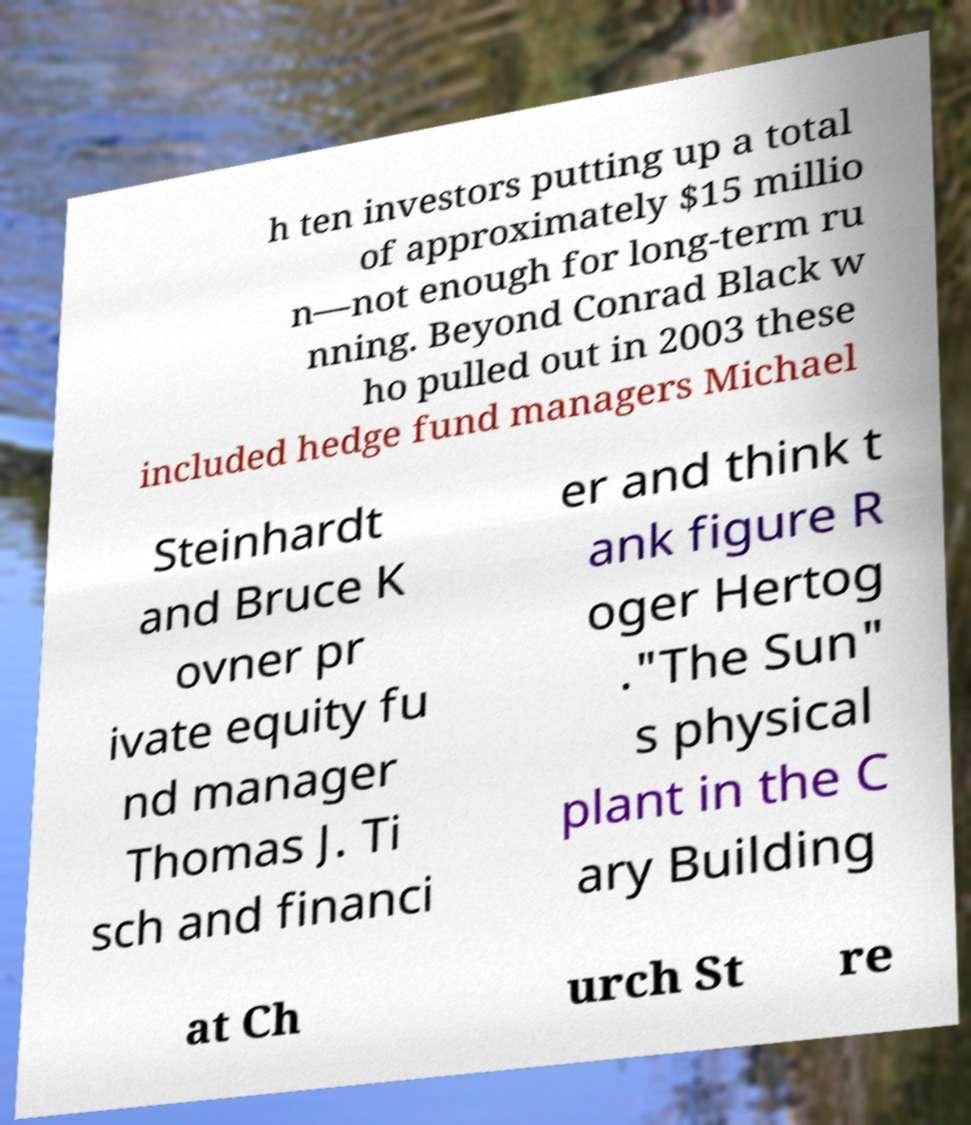For documentation purposes, I need the text within this image transcribed. Could you provide that? h ten investors putting up a total of approximately $15 millio n—not enough for long-term ru nning. Beyond Conrad Black w ho pulled out in 2003 these included hedge fund managers Michael Steinhardt and Bruce K ovner pr ivate equity fu nd manager Thomas J. Ti sch and financi er and think t ank figure R oger Hertog ."The Sun" s physical plant in the C ary Building at Ch urch St re 